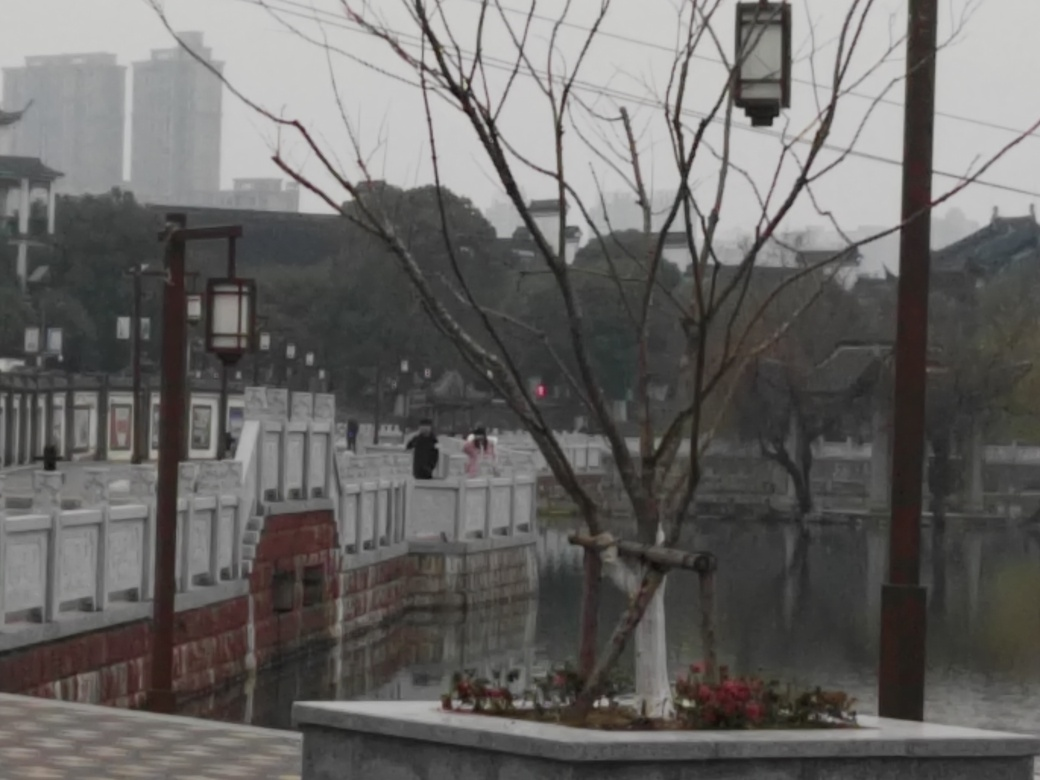What time of day does this image seem to depict? The overcast sky and absence of shadows suggest it may be either a cloudy midday or an approaching evening, creating a serene and slightly somber atmosphere. What mood does the image evoke? The image evokes a mood of tranquility and solitude. The cloudy weather and barren branches contribute to a peaceful yet contemplative feeling, as the few figures in the distance walk alongside the river, wrapped in their own thoughts. 